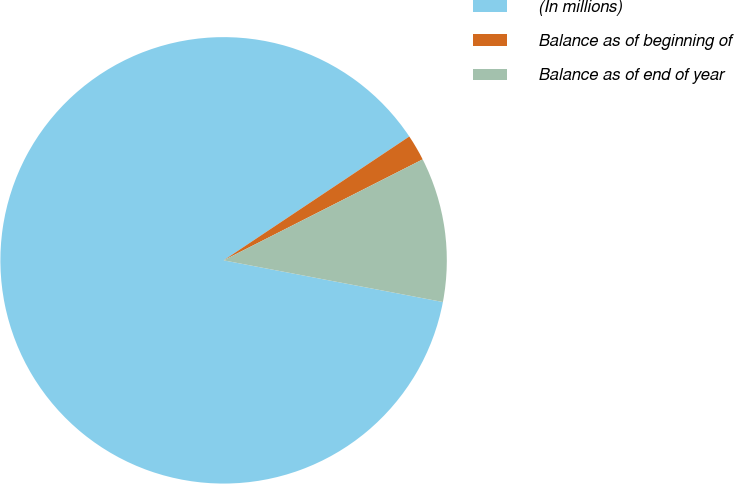Convert chart. <chart><loc_0><loc_0><loc_500><loc_500><pie_chart><fcel>(In millions)<fcel>Balance as of beginning of<fcel>Balance as of end of year<nl><fcel>87.65%<fcel>1.89%<fcel>10.46%<nl></chart> 